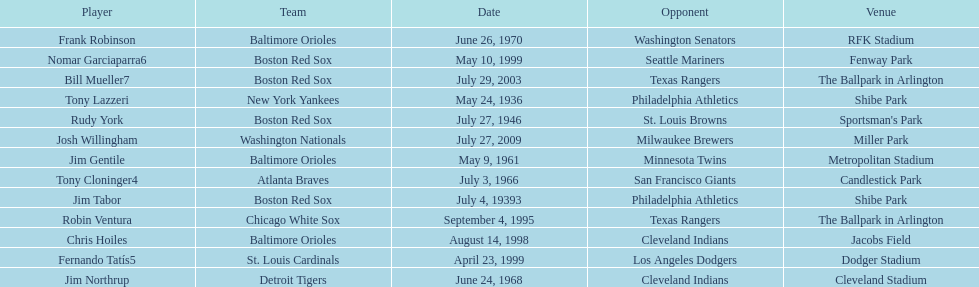What is the name of the player for the new york yankees in 1936? Tony Lazzeri. 